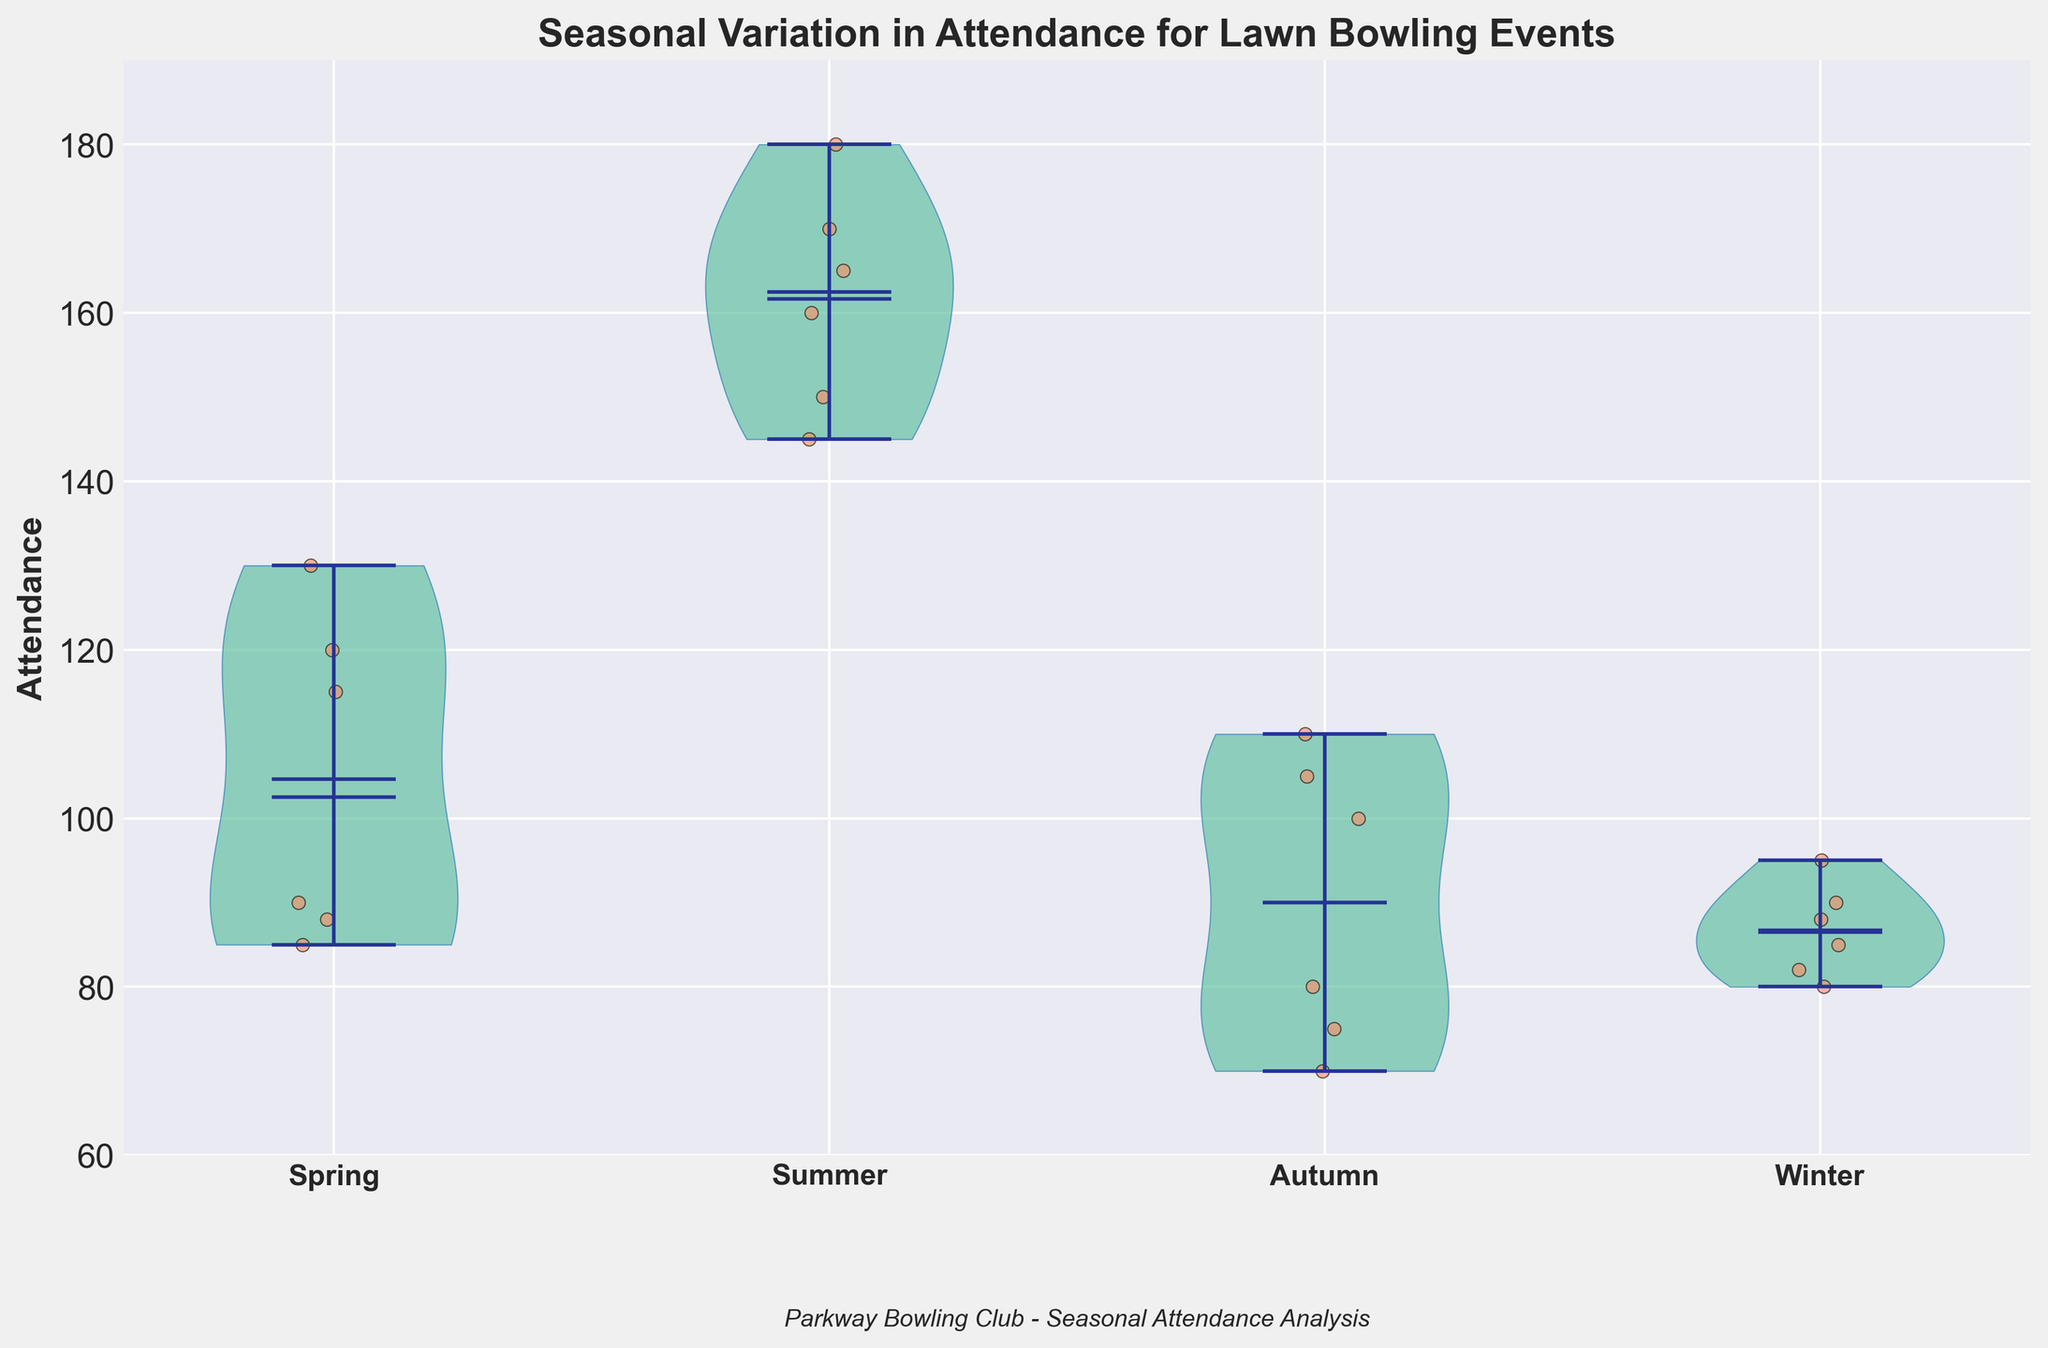What is the title of the figure? The title of the figure is placed at the top and helps identify what the data represents. It provides context for the visual information.
Answer: Seasonal Variation in Attendance for Lawn Bowling Events What are the seasons labeled on the x-axis? The x-axis labels indicate the categories being compared in the figure, which in this case are different seasons. The labels are prominently displayed under each violin plot.
Answer: Spring, Summer, Autumn, Winter Which season shows the highest median attendance? The median attendance can be identified by the horizontal line inside each violin plot. The highest of these lines across the different seasons indicates the season with the highest median attendance.
Answer: Summer What is the approximate median attendance for Winter? Look at the horizontal line inside the Winter violin plot, which represents the median attendance.
Answer: Around 87 Which season has the widest range in attendance? The range can be determined by the difference between the top and bottom vertical lines within each violin plot. Identify the longest distance between these extremes.
Answer: Summer How does the attendance distribution in Summer compare to Autumn? Compare the shapes of the violin plots for Summer and Autumn, noting aspects like the spread and concentration of the data points within the plots.
Answer: Summer has a higher and more spread-out distribution of attendance than Autumn What does the scatter of points around the violin plots represent? The scattered points add detailed information on each individual data point and show how spread out or concentrated the attendance values are within each season.
Answer: Individual attendance data points Which season has the lowest maximum attendance? Check the topmost point of each violin plot which represents the maximum attendance for that season. Compare these points across all seasons.
Answer: Winter How does the mean attendance in Spring compare to the mean attendance in Winter? The mean attendance is shown by a marker within each violin plot. Compare the height of these markers in Spring and Winter.
Answer: The mean attendance in Spring is higher than in Winter 